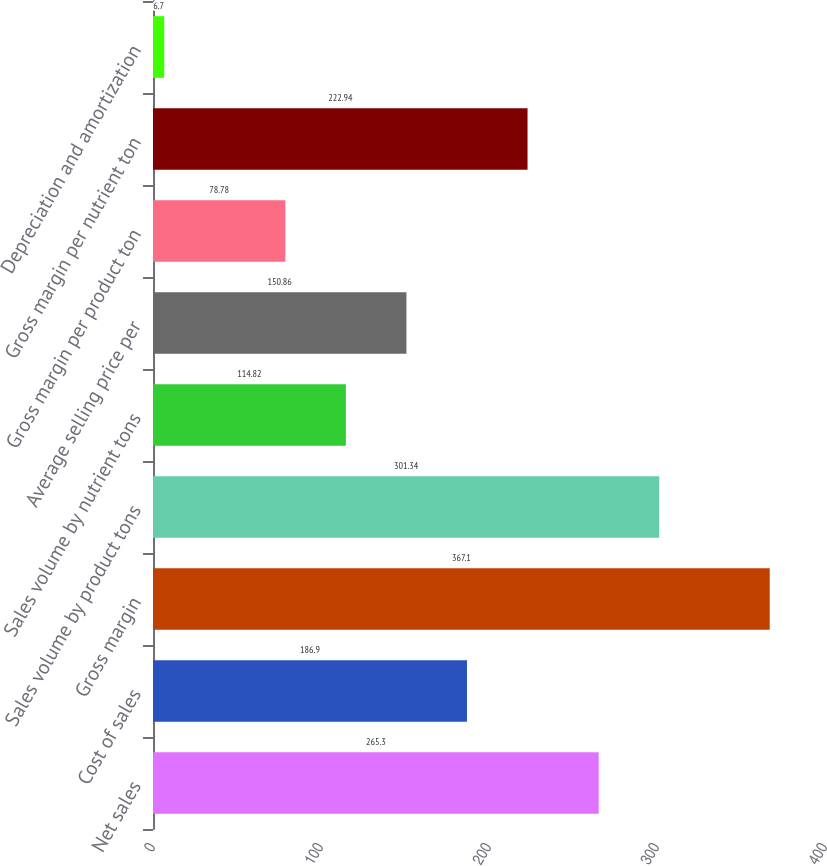Convert chart. <chart><loc_0><loc_0><loc_500><loc_500><bar_chart><fcel>Net sales<fcel>Cost of sales<fcel>Gross margin<fcel>Sales volume by product tons<fcel>Sales volume by nutrient tons<fcel>Average selling price per<fcel>Gross margin per product ton<fcel>Gross margin per nutrient ton<fcel>Depreciation and amortization<nl><fcel>265.3<fcel>186.9<fcel>367.1<fcel>301.34<fcel>114.82<fcel>150.86<fcel>78.78<fcel>222.94<fcel>6.7<nl></chart> 